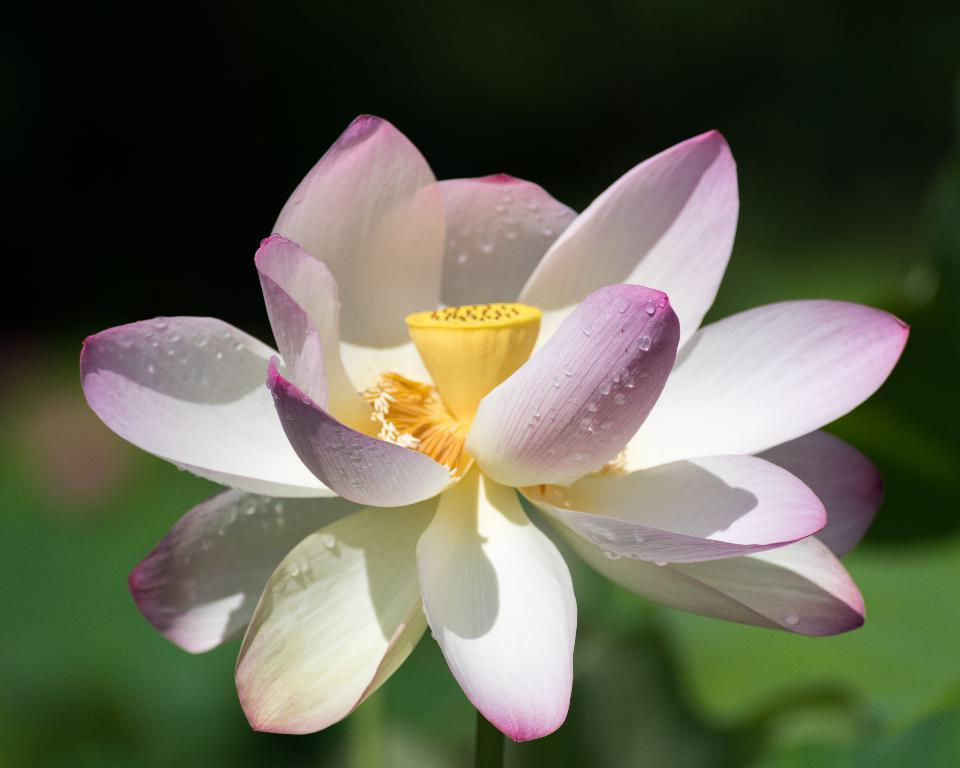What is the main subject of the picture? There is a flower in the center of the picture. What colors are the petals of the flower? The petals of the flower are white and violet in color. Can you describe any additional details about the flower? Yes, there are water droplets on the petals. How would you describe the background of the image? The background of the image is blurred. What time does the clock in the middle of the picture show? There is no clock present in the image; it features a flower with petals that are white and violet in color. What reward can be seen for achieving a certain goal in the image? There is no reward visible in the image; it only shows a flower with water droplets on its petals. 